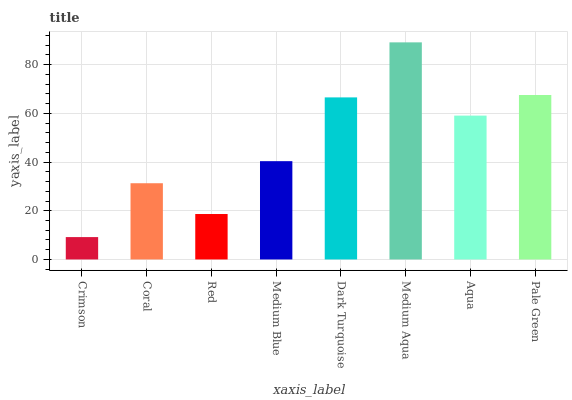Is Coral the minimum?
Answer yes or no. No. Is Coral the maximum?
Answer yes or no. No. Is Coral greater than Crimson?
Answer yes or no. Yes. Is Crimson less than Coral?
Answer yes or no. Yes. Is Crimson greater than Coral?
Answer yes or no. No. Is Coral less than Crimson?
Answer yes or no. No. Is Aqua the high median?
Answer yes or no. Yes. Is Medium Blue the low median?
Answer yes or no. Yes. Is Coral the high median?
Answer yes or no. No. Is Dark Turquoise the low median?
Answer yes or no. No. 